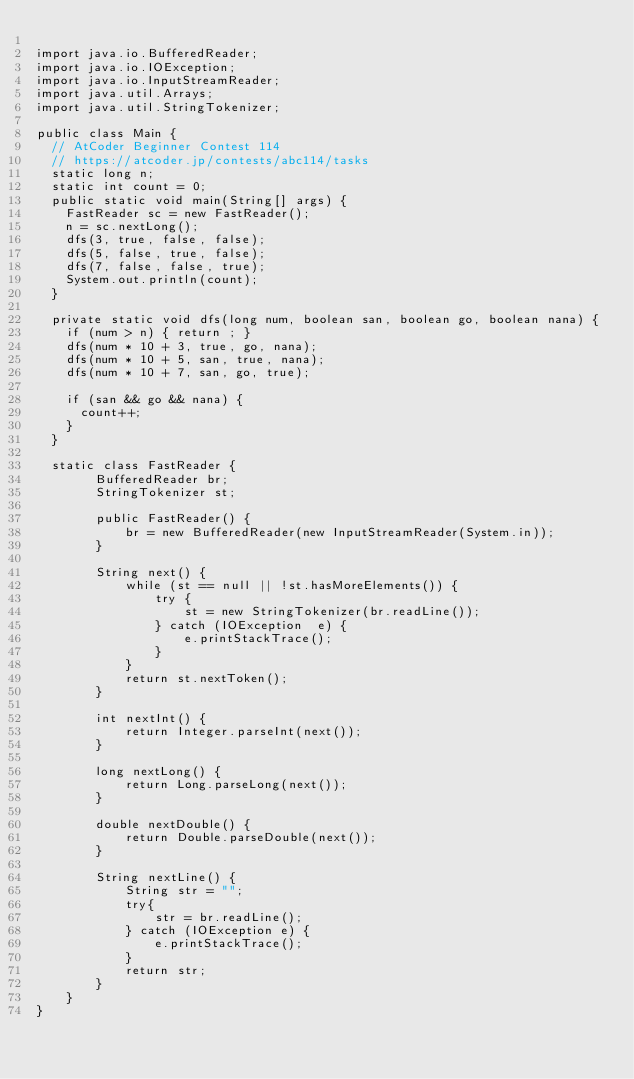Convert code to text. <code><loc_0><loc_0><loc_500><loc_500><_Java_>
import java.io.BufferedReader;
import java.io.IOException;
import java.io.InputStreamReader;
import java.util.Arrays;
import java.util.StringTokenizer;

public class Main {
	// AtCoder Beginner Contest 114
	// https://atcoder.jp/contests/abc114/tasks
	static long n;
	static int count = 0;
	public static void main(String[] args) {
		FastReader sc = new FastReader();
		n = sc.nextLong();
		dfs(3, true, false, false);
		dfs(5, false, true, false);
		dfs(7, false, false, true);
		System.out.println(count);
	}
	
	private static void dfs(long num, boolean san, boolean go, boolean nana) {
		if (num > n) { return ; }
		dfs(num * 10 + 3, true, go, nana);
		dfs(num * 10 + 5, san, true, nana);
		dfs(num * 10 + 7, san, go, true);
		
		if (san && go && nana) {
			count++;
		}
	}
	
	static class FastReader { 
        BufferedReader br; 
        StringTokenizer st; 
  
        public FastReader() { 
            br = new BufferedReader(new InputStreamReader(System.in)); 
        } 
  
        String next() { 
            while (st == null || !st.hasMoreElements()) { 
                try { 
                    st = new StringTokenizer(br.readLine()); 
                } catch (IOException  e) { 
                    e.printStackTrace(); 
                } 
            } 
            return st.nextToken(); 
        } 
  
        int nextInt() { 
            return Integer.parseInt(next()); 
        } 
  
        long nextLong() { 
            return Long.parseLong(next()); 
        } 
  
        double nextDouble() { 
            return Double.parseDouble(next()); 
        } 
  
        String nextLine() { 
            String str = ""; 
            try{ 
                str = br.readLine(); 
            } catch (IOException e) { 
                e.printStackTrace(); 
            } 
            return str; 
        } 
    } 
}
</code> 